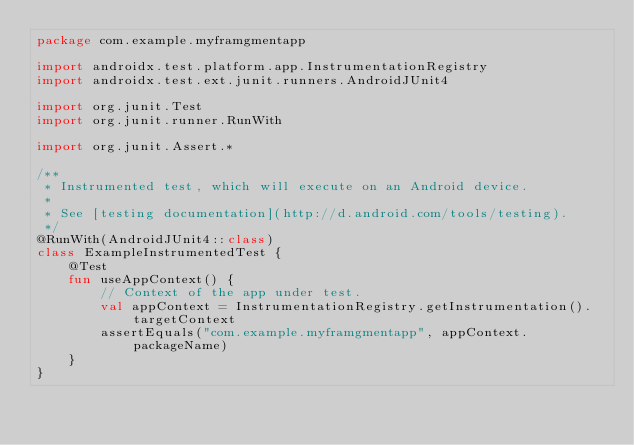<code> <loc_0><loc_0><loc_500><loc_500><_Kotlin_>package com.example.myframgmentapp

import androidx.test.platform.app.InstrumentationRegistry
import androidx.test.ext.junit.runners.AndroidJUnit4

import org.junit.Test
import org.junit.runner.RunWith

import org.junit.Assert.*

/**
 * Instrumented test, which will execute on an Android device.
 *
 * See [testing documentation](http://d.android.com/tools/testing).
 */
@RunWith(AndroidJUnit4::class)
class ExampleInstrumentedTest {
    @Test
    fun useAppContext() {
        // Context of the app under test.
        val appContext = InstrumentationRegistry.getInstrumentation().targetContext
        assertEquals("com.example.myframgmentapp", appContext.packageName)
    }
}
</code> 